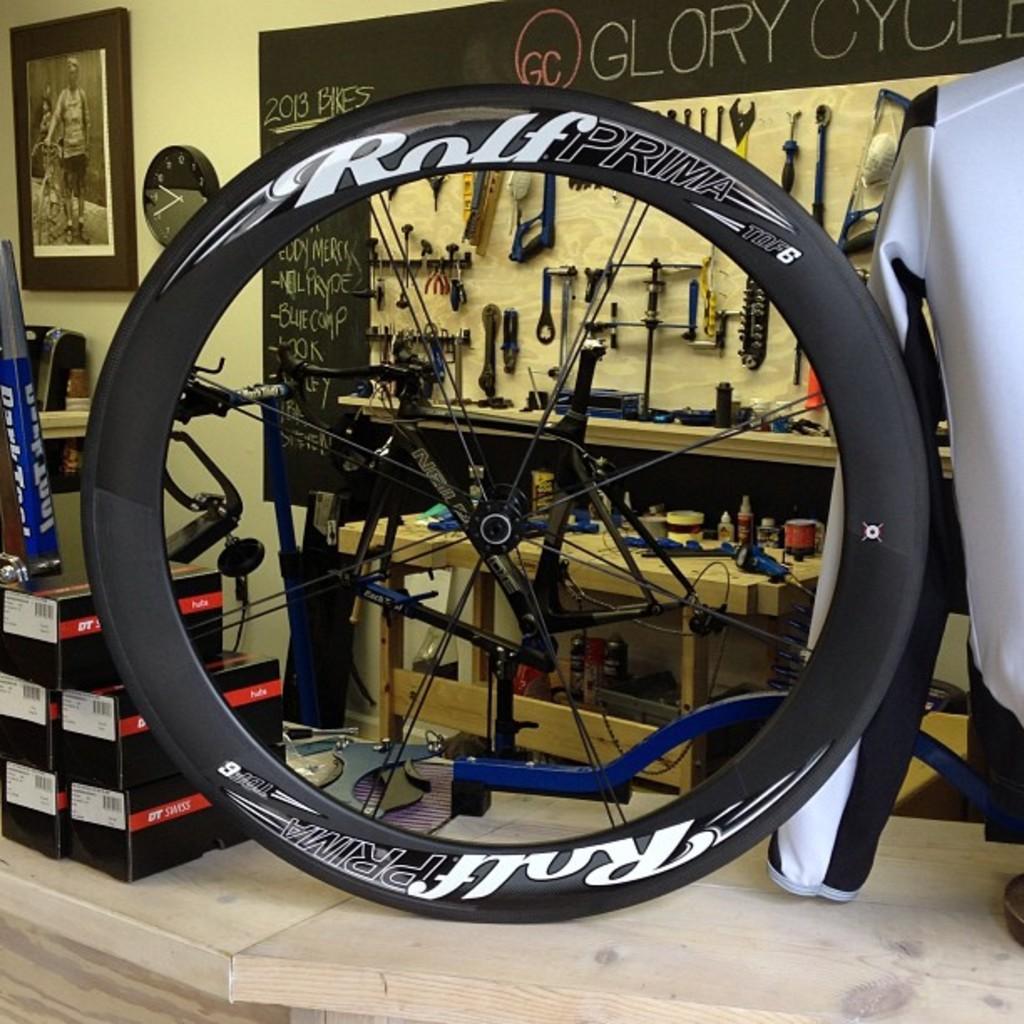Describe this image in one or two sentences. In this image we can see a wooden surface. On that we can see jacket, tire with text, boxes and few other things. In the back there is a wall with photo frame. Also there is a clock. And we can see parts of cycle. Also there is a table with racks. And there are bottles and many other items. And there is text on the wall. And there are tools hung on the wall. 